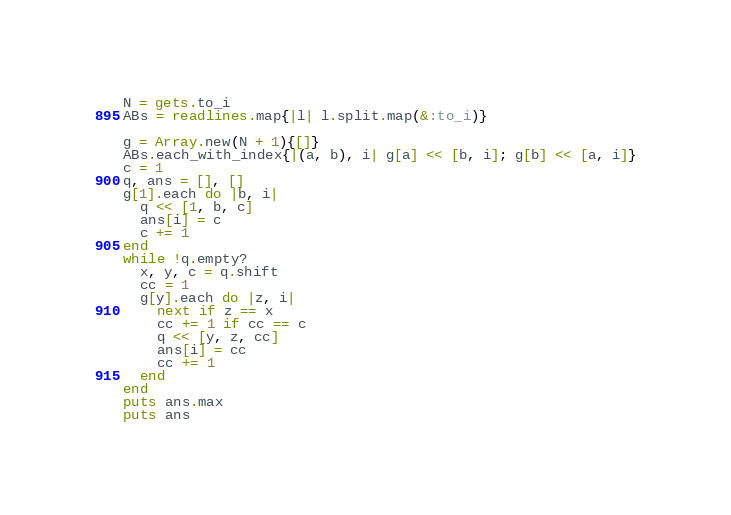Convert code to text. <code><loc_0><loc_0><loc_500><loc_500><_Ruby_>N = gets.to_i
ABs = readlines.map{|l| l.split.map(&:to_i)}

g = Array.new(N + 1){[]}
ABs.each_with_index{|(a, b), i| g[a] << [b, i]; g[b] << [a, i]}
c = 1
q, ans = [], []
g[1].each do |b, i|
  q << [1, b, c]
  ans[i] = c
  c += 1
end
while !q.empty?
  x, y, c = q.shift
  cc = 1
  g[y].each do |z, i|
    next if z == x
    cc += 1 if cc == c
    q << [y, z, cc]
    ans[i] = cc
    cc += 1
  end
end
puts ans.max
puts ans</code> 